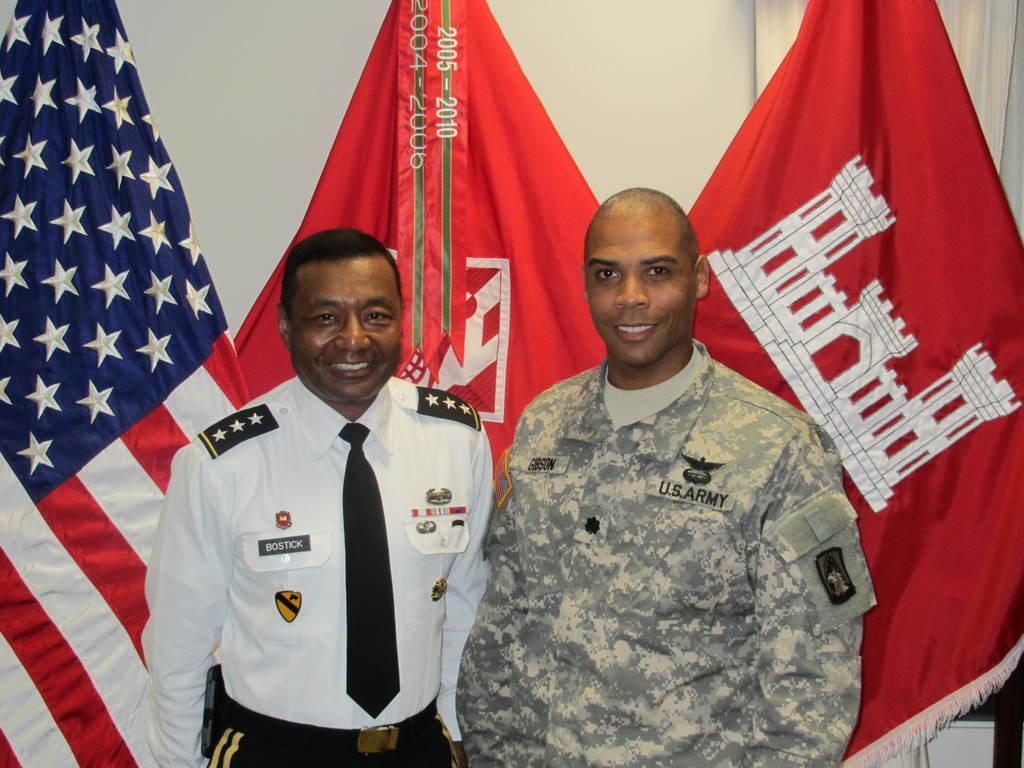How many people are in the image? There are two persons in the image. What are the people doing in the image? Both persons are standing and smiling. What can be seen in the background of the image? There are flag posts visible in the background of the image. What do the flag posts represent? The flag posts represent different countries. How many daughters does the person on the left have in the image? There is no information about daughters or family relationships in the image. What type of ants can be seen crawling on the feet of the person on the right? There are no ants present in the image. 